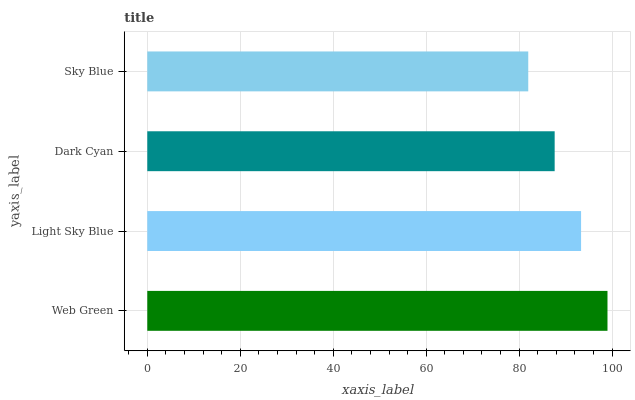Is Sky Blue the minimum?
Answer yes or no. Yes. Is Web Green the maximum?
Answer yes or no. Yes. Is Light Sky Blue the minimum?
Answer yes or no. No. Is Light Sky Blue the maximum?
Answer yes or no. No. Is Web Green greater than Light Sky Blue?
Answer yes or no. Yes. Is Light Sky Blue less than Web Green?
Answer yes or no. Yes. Is Light Sky Blue greater than Web Green?
Answer yes or no. No. Is Web Green less than Light Sky Blue?
Answer yes or no. No. Is Light Sky Blue the high median?
Answer yes or no. Yes. Is Dark Cyan the low median?
Answer yes or no. Yes. Is Dark Cyan the high median?
Answer yes or no. No. Is Web Green the low median?
Answer yes or no. No. 